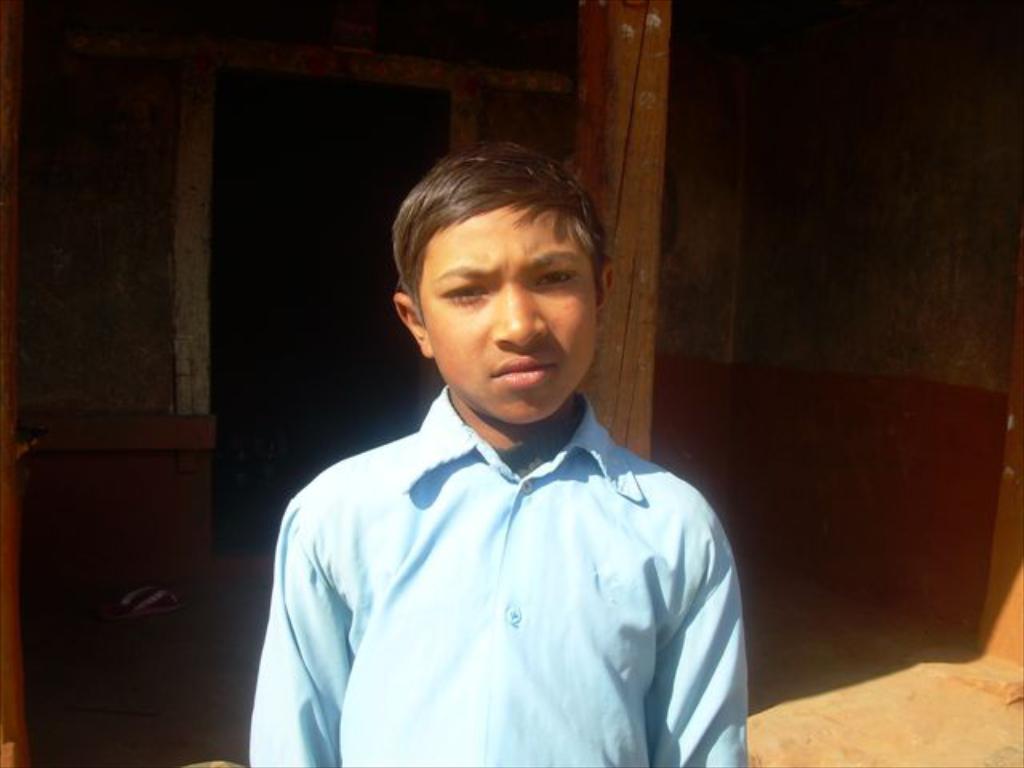Can you describe this image briefly? This is the man standing. He wore a blue shirt. This looks like a wooden pillar. In the background, I think this is the small house. This looks like a footwear. 